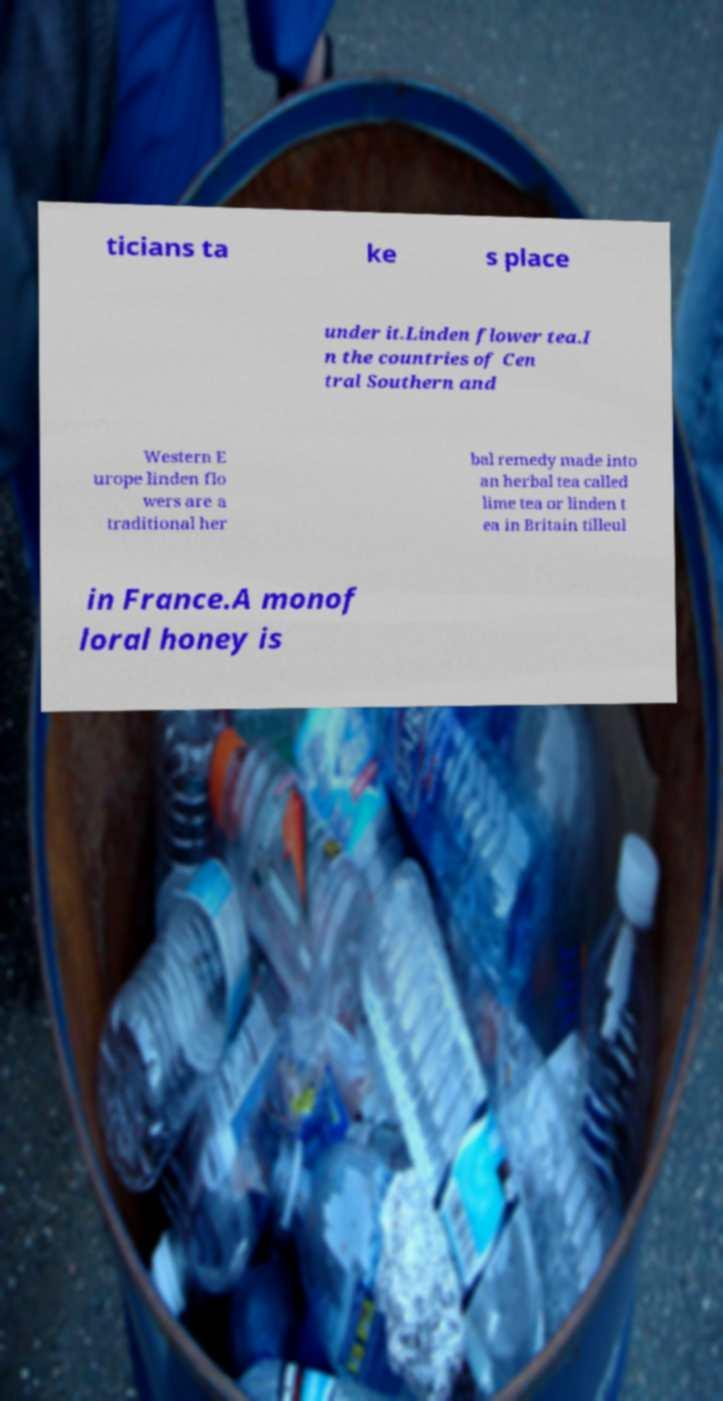Could you extract and type out the text from this image? ticians ta ke s place under it.Linden flower tea.I n the countries of Cen tral Southern and Western E urope linden flo wers are a traditional her bal remedy made into an herbal tea called lime tea or linden t ea in Britain tilleul in France.A monof loral honey is 